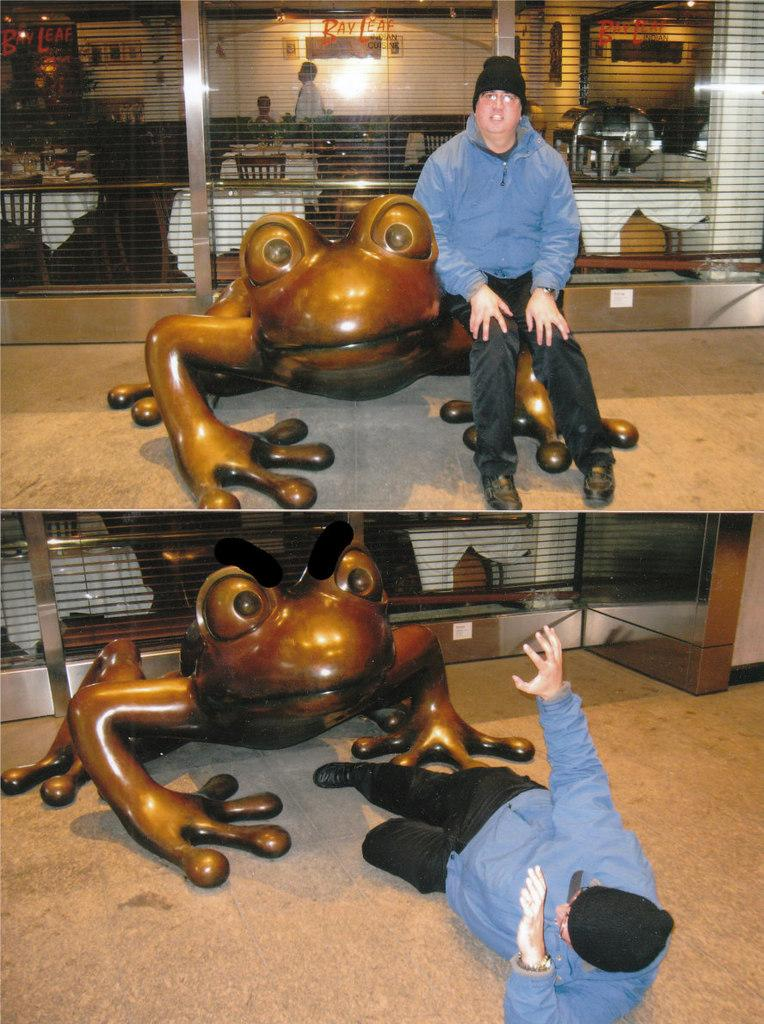What type of artwork is the image? The image is a collage. Can you describe the people in the image? There are people in the image, but their specific characteristics are not mentioned in the facts. What type of furniture is present in the image? There are chairs and tables in the image. What is the background of the image? There is a wall in the image. What type of lighting is present in the image? There are lights in the image. What other objects can be seen in the image? There are other objects in the image, but their specific details are not mentioned in the facts. Where is the heart located in the image? There is no heart present in the image; it is a collage featuring people, chairs, tables, a wall, and lights. What type of wealth is depicted in the image? There is no depiction of wealth in the image; it is a collage featuring people, chairs, tables, a wall, and lights. 